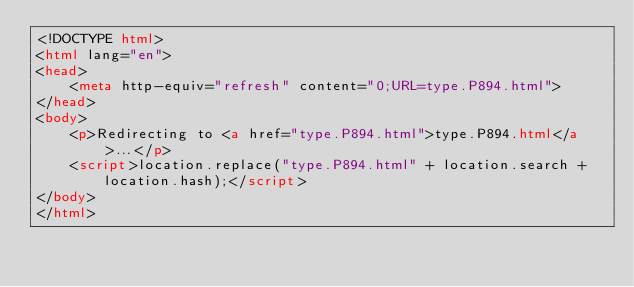<code> <loc_0><loc_0><loc_500><loc_500><_HTML_><!DOCTYPE html>
<html lang="en">
<head>
    <meta http-equiv="refresh" content="0;URL=type.P894.html">
</head>
<body>
    <p>Redirecting to <a href="type.P894.html">type.P894.html</a>...</p>
    <script>location.replace("type.P894.html" + location.search + location.hash);</script>
</body>
</html></code> 